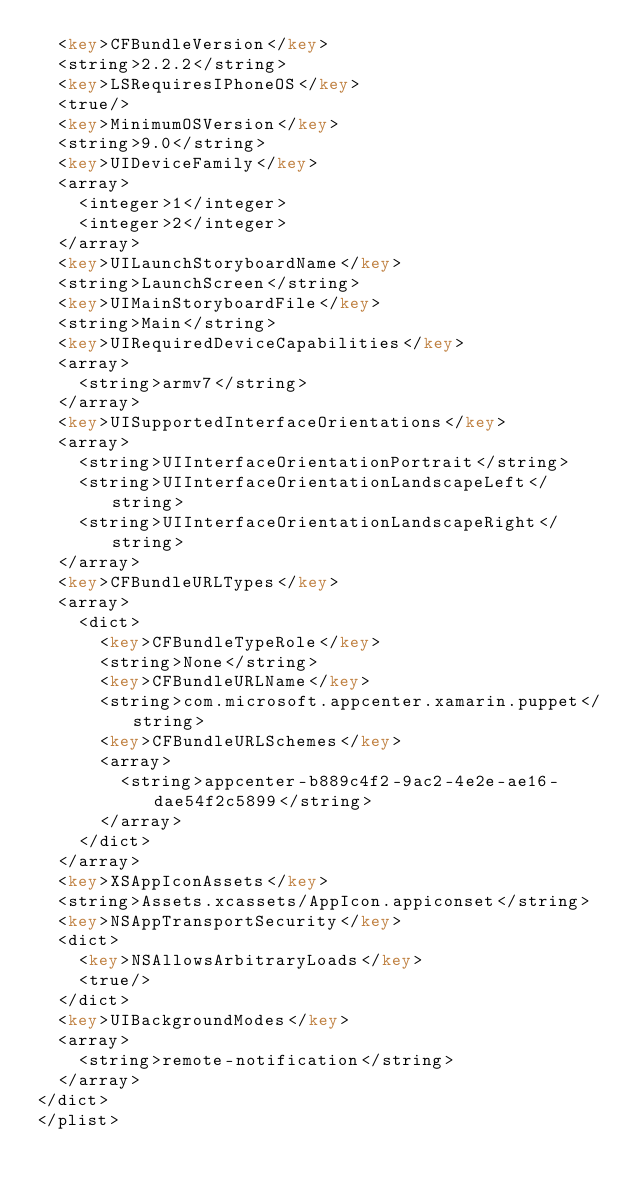Convert code to text. <code><loc_0><loc_0><loc_500><loc_500><_XML_>	<key>CFBundleVersion</key>
	<string>2.2.2</string>
	<key>LSRequiresIPhoneOS</key>
	<true/>
	<key>MinimumOSVersion</key>
	<string>9.0</string>
	<key>UIDeviceFamily</key>
	<array>
		<integer>1</integer>
		<integer>2</integer>
	</array>
	<key>UILaunchStoryboardName</key>
	<string>LaunchScreen</string>
	<key>UIMainStoryboardFile</key>
	<string>Main</string>
	<key>UIRequiredDeviceCapabilities</key>
	<array>
		<string>armv7</string>
	</array>
	<key>UISupportedInterfaceOrientations</key>
	<array>
		<string>UIInterfaceOrientationPortrait</string>
		<string>UIInterfaceOrientationLandscapeLeft</string>
		<string>UIInterfaceOrientationLandscapeRight</string>
	</array>
	<key>CFBundleURLTypes</key>
	<array>
		<dict>
			<key>CFBundleTypeRole</key>
			<string>None</string>
			<key>CFBundleURLName</key>
			<string>com.microsoft.appcenter.xamarin.puppet</string>
			<key>CFBundleURLSchemes</key>
			<array>
				<string>appcenter-b889c4f2-9ac2-4e2e-ae16-dae54f2c5899</string>
			</array>
		</dict>
	</array>
	<key>XSAppIconAssets</key>
	<string>Assets.xcassets/AppIcon.appiconset</string>
	<key>NSAppTransportSecurity</key>
	<dict>
		<key>NSAllowsArbitraryLoads</key>
		<true/>
	</dict>
	<key>UIBackgroundModes</key>
	<array>
		<string>remote-notification</string>
	</array>
</dict>
</plist>
</code> 